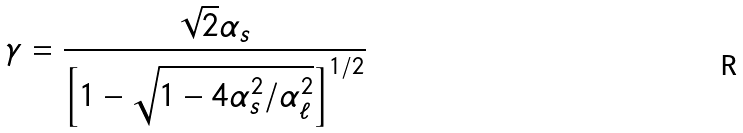Convert formula to latex. <formula><loc_0><loc_0><loc_500><loc_500>\gamma = \frac { \sqrt { 2 } \alpha _ { s } } { \left [ 1 - \sqrt { 1 - 4 \alpha _ { s } ^ { 2 } / \alpha _ { \ell } ^ { 2 } } \right ] ^ { 1 / 2 } }</formula> 